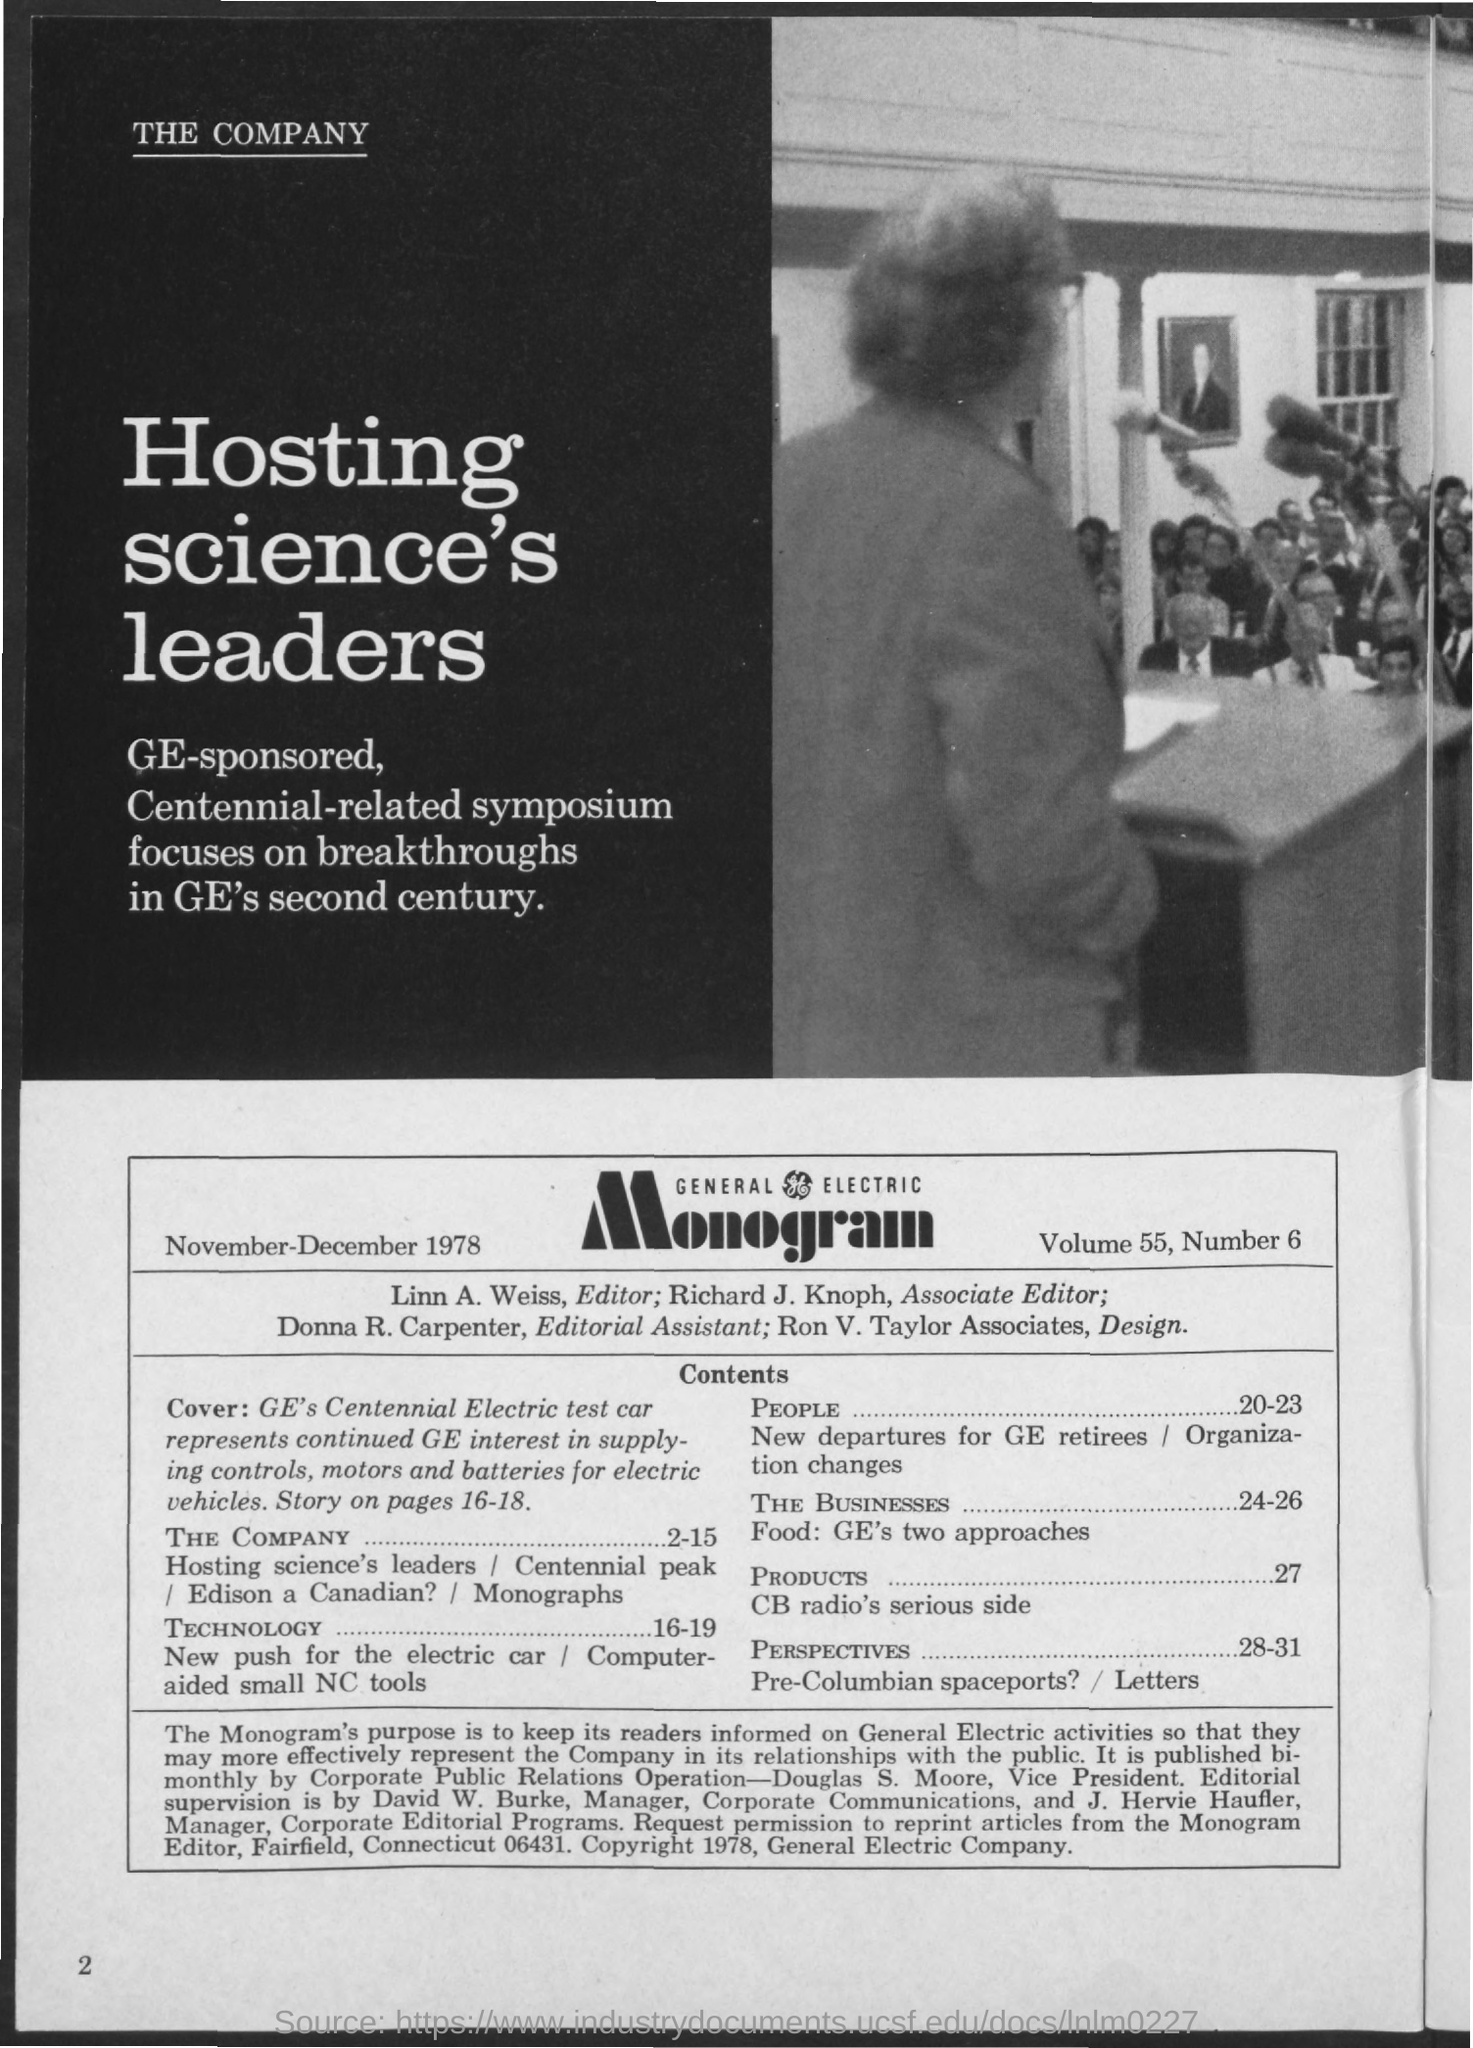What is the date on the document?
Ensure brevity in your answer.  November-December 1978. What is the Volume?
Provide a succinct answer. 55. What is the Number?
Your response must be concise. 6. Who is the Editor?
Your answer should be compact. Linn. A. Weiss. Who is the Associate Editor?
Your answer should be very brief. Richard J. Knoph. Who is the Editorial Assistant?
Your answer should be very brief. Donna R. Carpenter. 